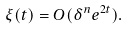<formula> <loc_0><loc_0><loc_500><loc_500>\xi ( t ) = O ( \delta ^ { n } e ^ { 2 t } ) .</formula> 